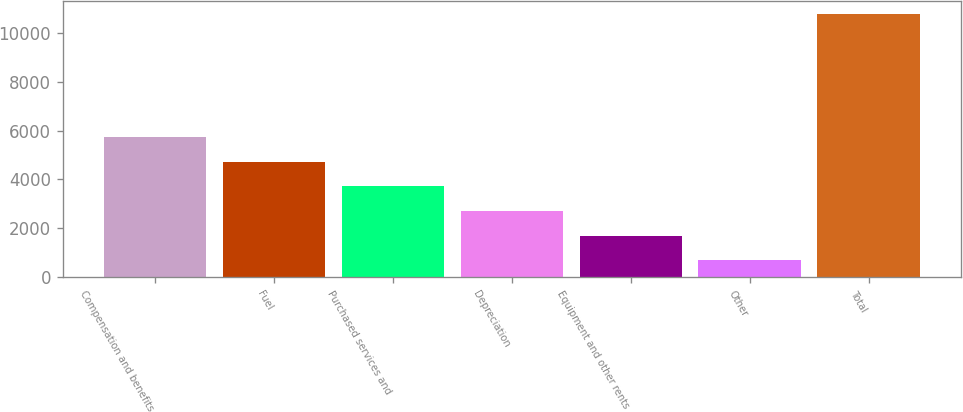Convert chart. <chart><loc_0><loc_0><loc_500><loc_500><bar_chart><fcel>Compensation and benefits<fcel>Fuel<fcel>Purchased services and<fcel>Depreciation<fcel>Equipment and other rents<fcel>Other<fcel>Total<nl><fcel>5725.5<fcel>4717.8<fcel>3710.1<fcel>2702.4<fcel>1694.7<fcel>687<fcel>10764<nl></chart> 